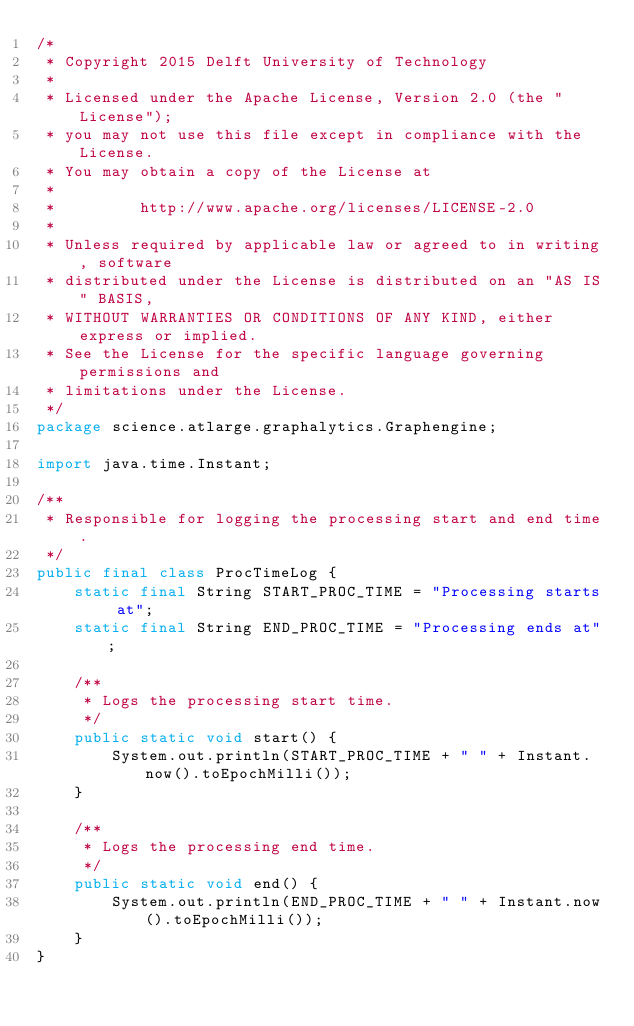<code> <loc_0><loc_0><loc_500><loc_500><_Java_>/*
 * Copyright 2015 Delft University of Technology
 *
 * Licensed under the Apache License, Version 2.0 (the "License");
 * you may not use this file except in compliance with the License.
 * You may obtain a copy of the License at
 *
 *         http://www.apache.org/licenses/LICENSE-2.0
 *
 * Unless required by applicable law or agreed to in writing, software
 * distributed under the License is distributed on an "AS IS" BASIS,
 * WITHOUT WARRANTIES OR CONDITIONS OF ANY KIND, either express or implied.
 * See the License for the specific language governing permissions and
 * limitations under the License.
 */
package science.atlarge.graphalytics.Graphengine;

import java.time.Instant;

/**
 * Responsible for logging the processing start and end time.
 */
public final class ProcTimeLog {
    static final String START_PROC_TIME = "Processing starts at";
    static final String END_PROC_TIME = "Processing ends at";

    /**
     * Logs the processing start time.
     */
    public static void start() {
        System.out.println(START_PROC_TIME + " " + Instant.now().toEpochMilli());
    }

    /**
     * Logs the processing end time.
     */
    public static void end() {
        System.out.println(END_PROC_TIME + " " + Instant.now().toEpochMilli());
    }
}</code> 